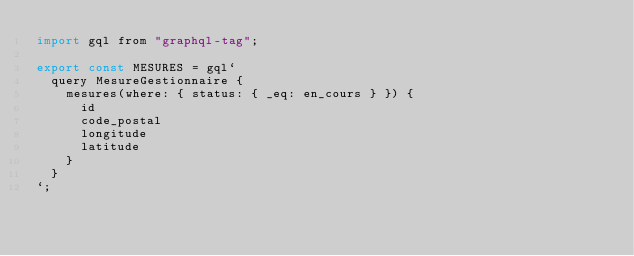Convert code to text. <code><loc_0><loc_0><loc_500><loc_500><_JavaScript_>import gql from "graphql-tag";

export const MESURES = gql`
  query MesureGestionnaire {
    mesures(where: { status: { _eq: en_cours } }) {
      id
      code_postal
      longitude
      latitude
    }
  }
`;
</code> 